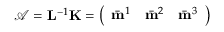Convert formula to latex. <formula><loc_0><loc_0><loc_500><loc_500>\mathcal { A } = L ^ { - 1 } K = \left ( \begin{array} { c c c } { \bar { m } ^ { 1 } } & { \bar { m } ^ { 2 } } & { \bar { m } ^ { 3 } } \end{array} \right )</formula> 